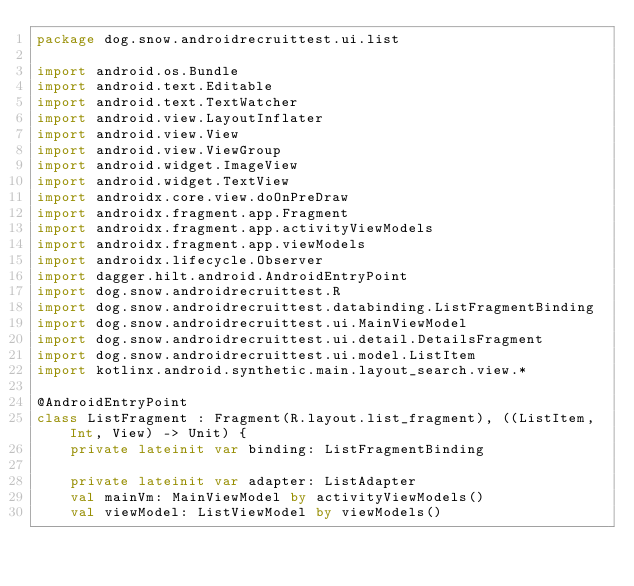<code> <loc_0><loc_0><loc_500><loc_500><_Kotlin_>package dog.snow.androidrecruittest.ui.list

import android.os.Bundle
import android.text.Editable
import android.text.TextWatcher
import android.view.LayoutInflater
import android.view.View
import android.view.ViewGroup
import android.widget.ImageView
import android.widget.TextView
import androidx.core.view.doOnPreDraw
import androidx.fragment.app.Fragment
import androidx.fragment.app.activityViewModels
import androidx.fragment.app.viewModels
import androidx.lifecycle.Observer
import dagger.hilt.android.AndroidEntryPoint
import dog.snow.androidrecruittest.R
import dog.snow.androidrecruittest.databinding.ListFragmentBinding
import dog.snow.androidrecruittest.ui.MainViewModel
import dog.snow.androidrecruittest.ui.detail.DetailsFragment
import dog.snow.androidrecruittest.ui.model.ListItem
import kotlinx.android.synthetic.main.layout_search.view.*

@AndroidEntryPoint
class ListFragment : Fragment(R.layout.list_fragment), ((ListItem, Int, View) -> Unit) {
    private lateinit var binding: ListFragmentBinding

    private lateinit var adapter: ListAdapter
    val mainVm: MainViewModel by activityViewModels()
    val viewModel: ListViewModel by viewModels()
</code> 